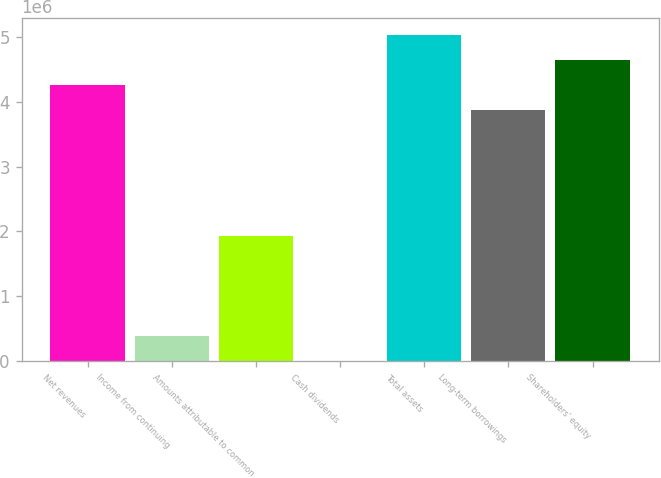<chart> <loc_0><loc_0><loc_500><loc_500><bar_chart><fcel>Net revenues<fcel>Income from continuing<fcel>Amounts attributable to common<fcel>Cash dividends<fcel>Total assets<fcel>Long-term borrowings<fcel>Shareholders' equity<nl><fcel>4.25895e+06<fcel>387179<fcel>1.93589e+06<fcel>1.36<fcel>5.03331e+06<fcel>3.87177e+06<fcel>4.64613e+06<nl></chart> 